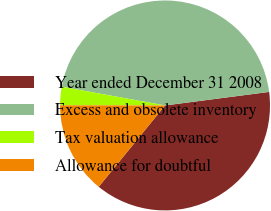Convert chart. <chart><loc_0><loc_0><loc_500><loc_500><pie_chart><fcel>Year ended December 31 2008<fcel>Excess and obsolete inventory<fcel>Tax valuation allowance<fcel>Allowance for doubtful<nl><fcel>37.94%<fcel>45.09%<fcel>2.83%<fcel>14.14%<nl></chart> 